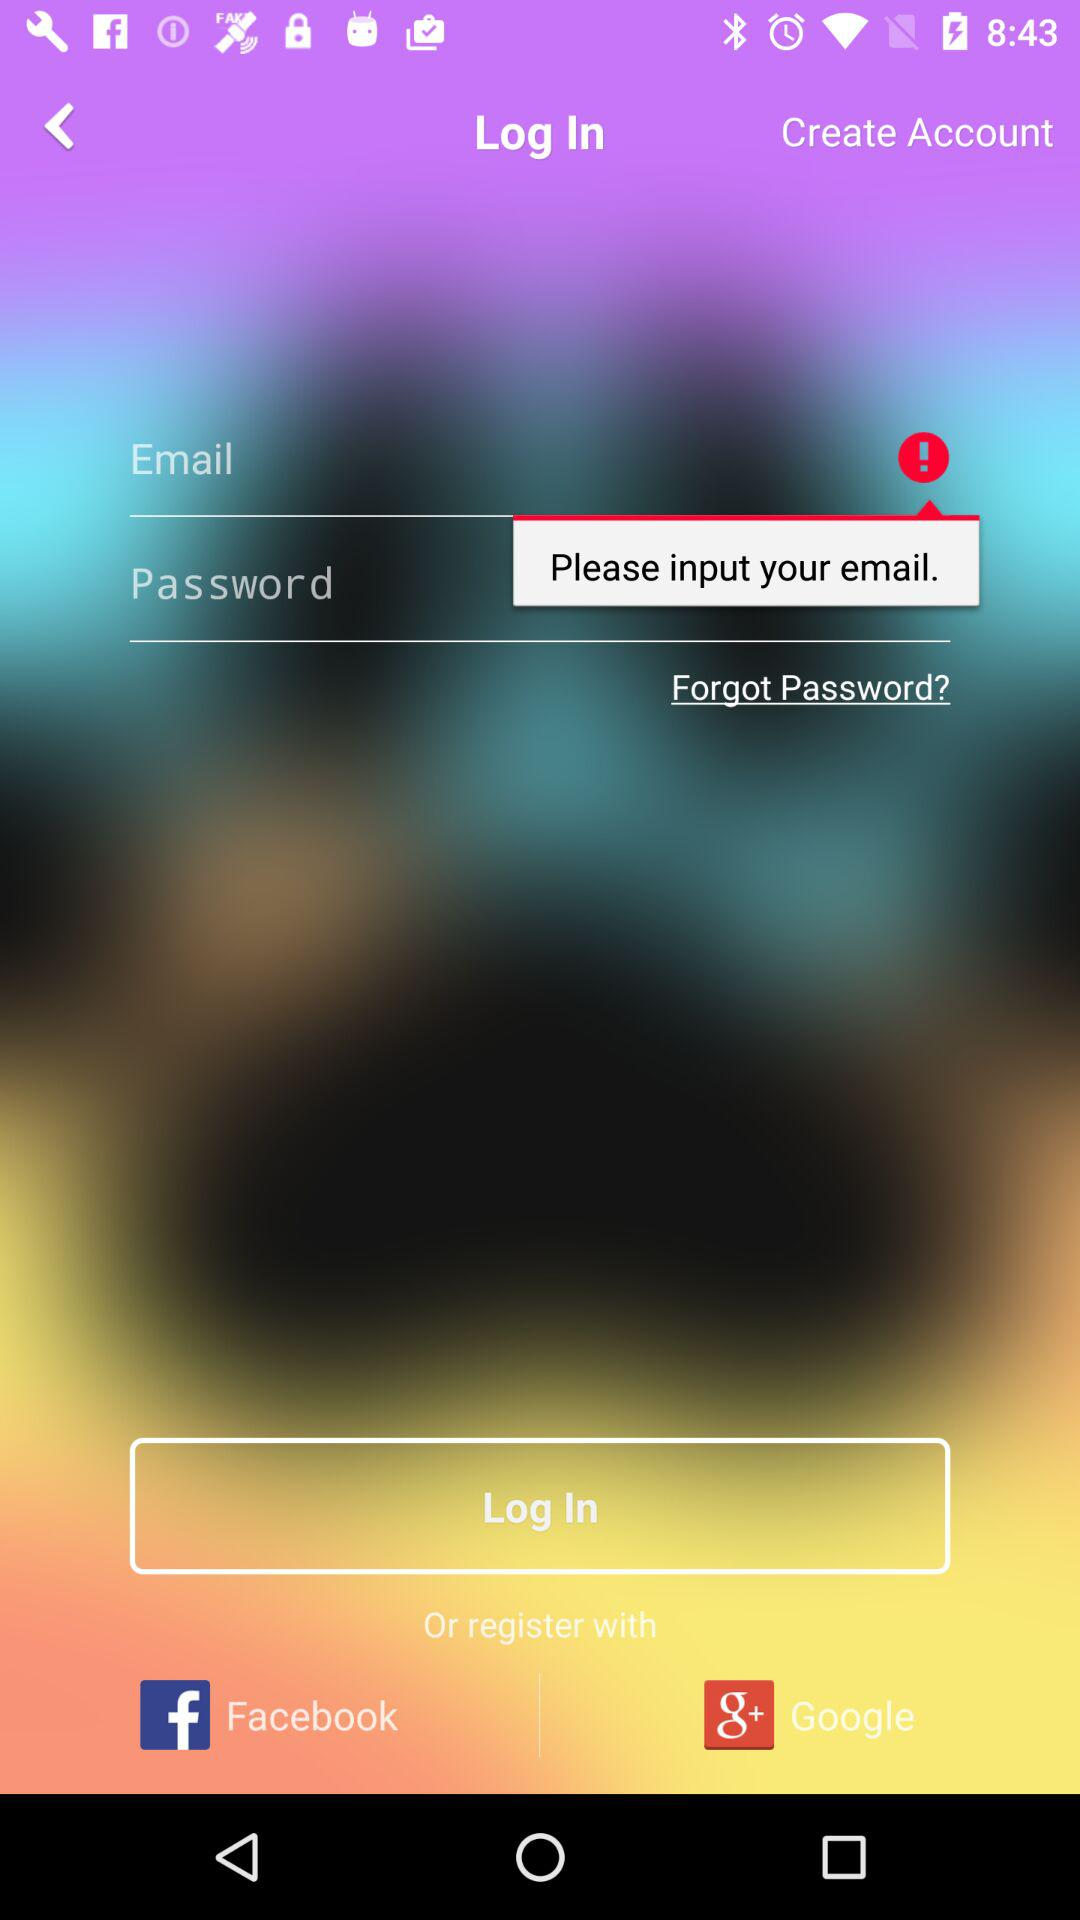What are the different options available for logging in? The different options available for logging in are "Email", "Facebook" and "Google+". 